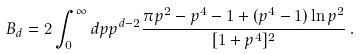Convert formula to latex. <formula><loc_0><loc_0><loc_500><loc_500>B _ { d } = 2 \int _ { 0 } ^ { \infty } d p { p } ^ { d - 2 } \frac { \pi p ^ { 2 } - p ^ { 4 } - 1 + ( p ^ { 4 } - 1 ) \ln p ^ { 2 } } { [ 1 + p ^ { 4 } ] ^ { 2 } } \, .</formula> 